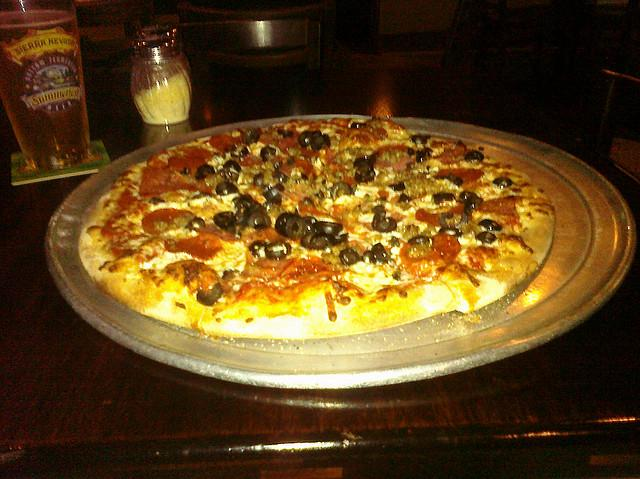What is in the shaker jar next to the beverage?

Choices:
A) hot peppers
B) parmesan cheese
C) sugar
D) salt parmesan cheese 